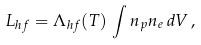<formula> <loc_0><loc_0><loc_500><loc_500>L _ { h f } = \Lambda _ { h f } ( T ) \, \int n _ { p } n _ { e } \, d V \, ,</formula> 